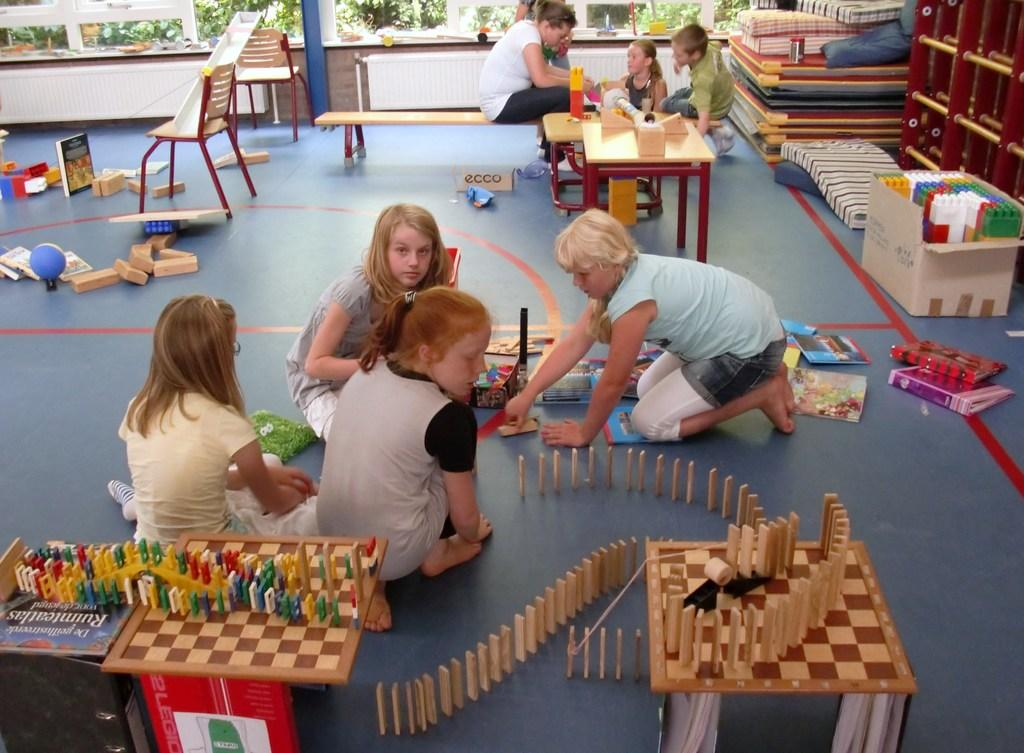Who is present in the image? There are children in the image. What are the children doing in the image? The children are playing in the image. What are the children playing with in the image? The children are playing with toys in the image. What type of tax can be seen being paid by the children in the image? There is no tax being paid by the children in the image; they are playing with toys. What kind of waves can be seen in the image? There are no waves present in the image; it features children playing with toys. 